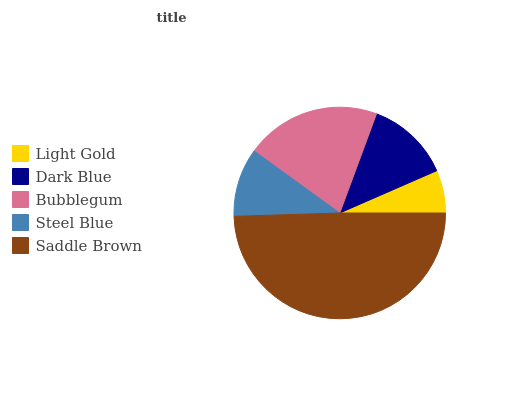Is Light Gold the minimum?
Answer yes or no. Yes. Is Saddle Brown the maximum?
Answer yes or no. Yes. Is Dark Blue the minimum?
Answer yes or no. No. Is Dark Blue the maximum?
Answer yes or no. No. Is Dark Blue greater than Light Gold?
Answer yes or no. Yes. Is Light Gold less than Dark Blue?
Answer yes or no. Yes. Is Light Gold greater than Dark Blue?
Answer yes or no. No. Is Dark Blue less than Light Gold?
Answer yes or no. No. Is Dark Blue the high median?
Answer yes or no. Yes. Is Dark Blue the low median?
Answer yes or no. Yes. Is Steel Blue the high median?
Answer yes or no. No. Is Light Gold the low median?
Answer yes or no. No. 